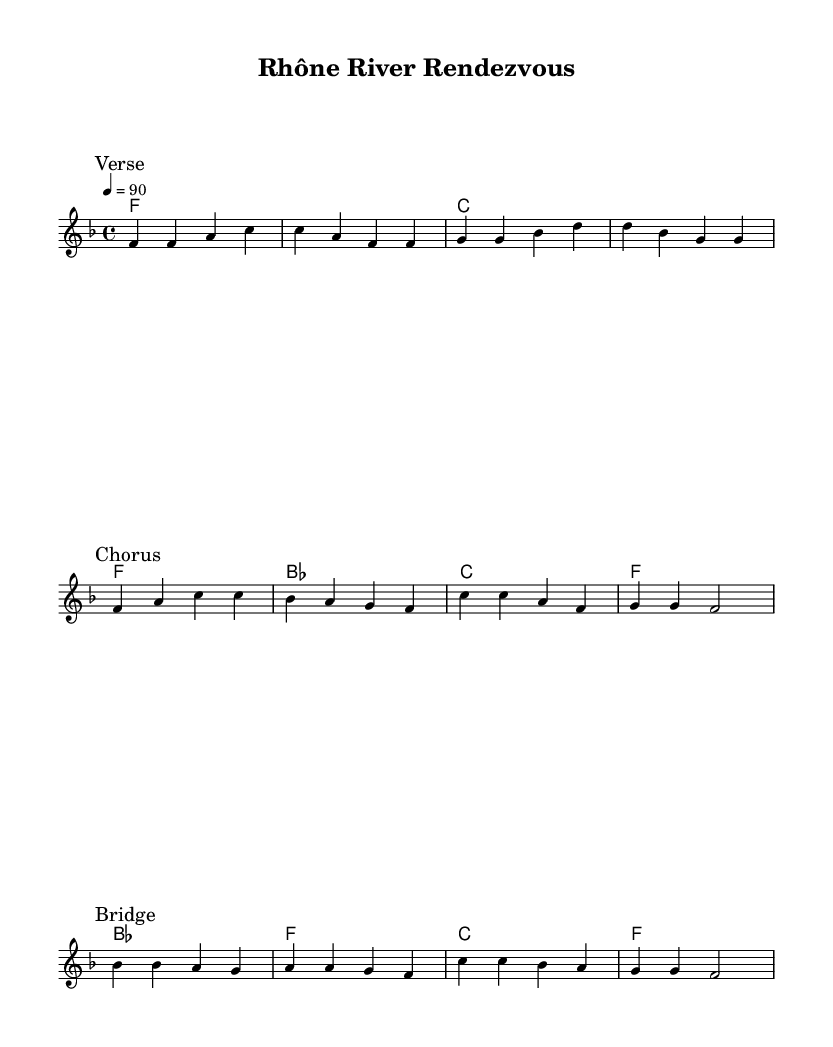What is the key signature of this music? The key signature is determined by the sharps and flats indicated at the beginning of the score. In this case, there are no sharps or flats shown, which signifies that the piece is in F major.
Answer: F major What is the time signature of this music? The time signature can be found next to the key signature at the beginning of the score. Here, it shows 4/4, meaning there are four beats per measure and the quarter note gets one beat.
Answer: 4/4 What is the tempo marking of this music? The tempo is indicated in beats per minute (bpm) at the top of the score. It states "4 = 90," meaning there are 90 beats per minute.
Answer: 90 How many sections are identifiable in the structure of this piece? By examining the distinct markings such as "Verse," "Chorus," and "Bridge," we can determine that there are three identifiable sections in the piece.
Answer: Three Which chord precedes the chorus in the harmony section? To find the chord that comes before the chorus, we look at the harmony section's layout carefully. The chord sequence listed shows that a F chord is played right before the chorus begins.
Answer: F What kind of musical ensemble is indicated by the score layout? The score layout includes a staff for melody and a section for chord names, suggesting this piece is written for a vocal or instrumental performance ensemble where both melody and harmony are present.
Answer: Vocal or instrumental ensemble What is the starting note of the melody in the first verse? The first note in the melody indicated under the "Verse" marking is F.
Answer: F 